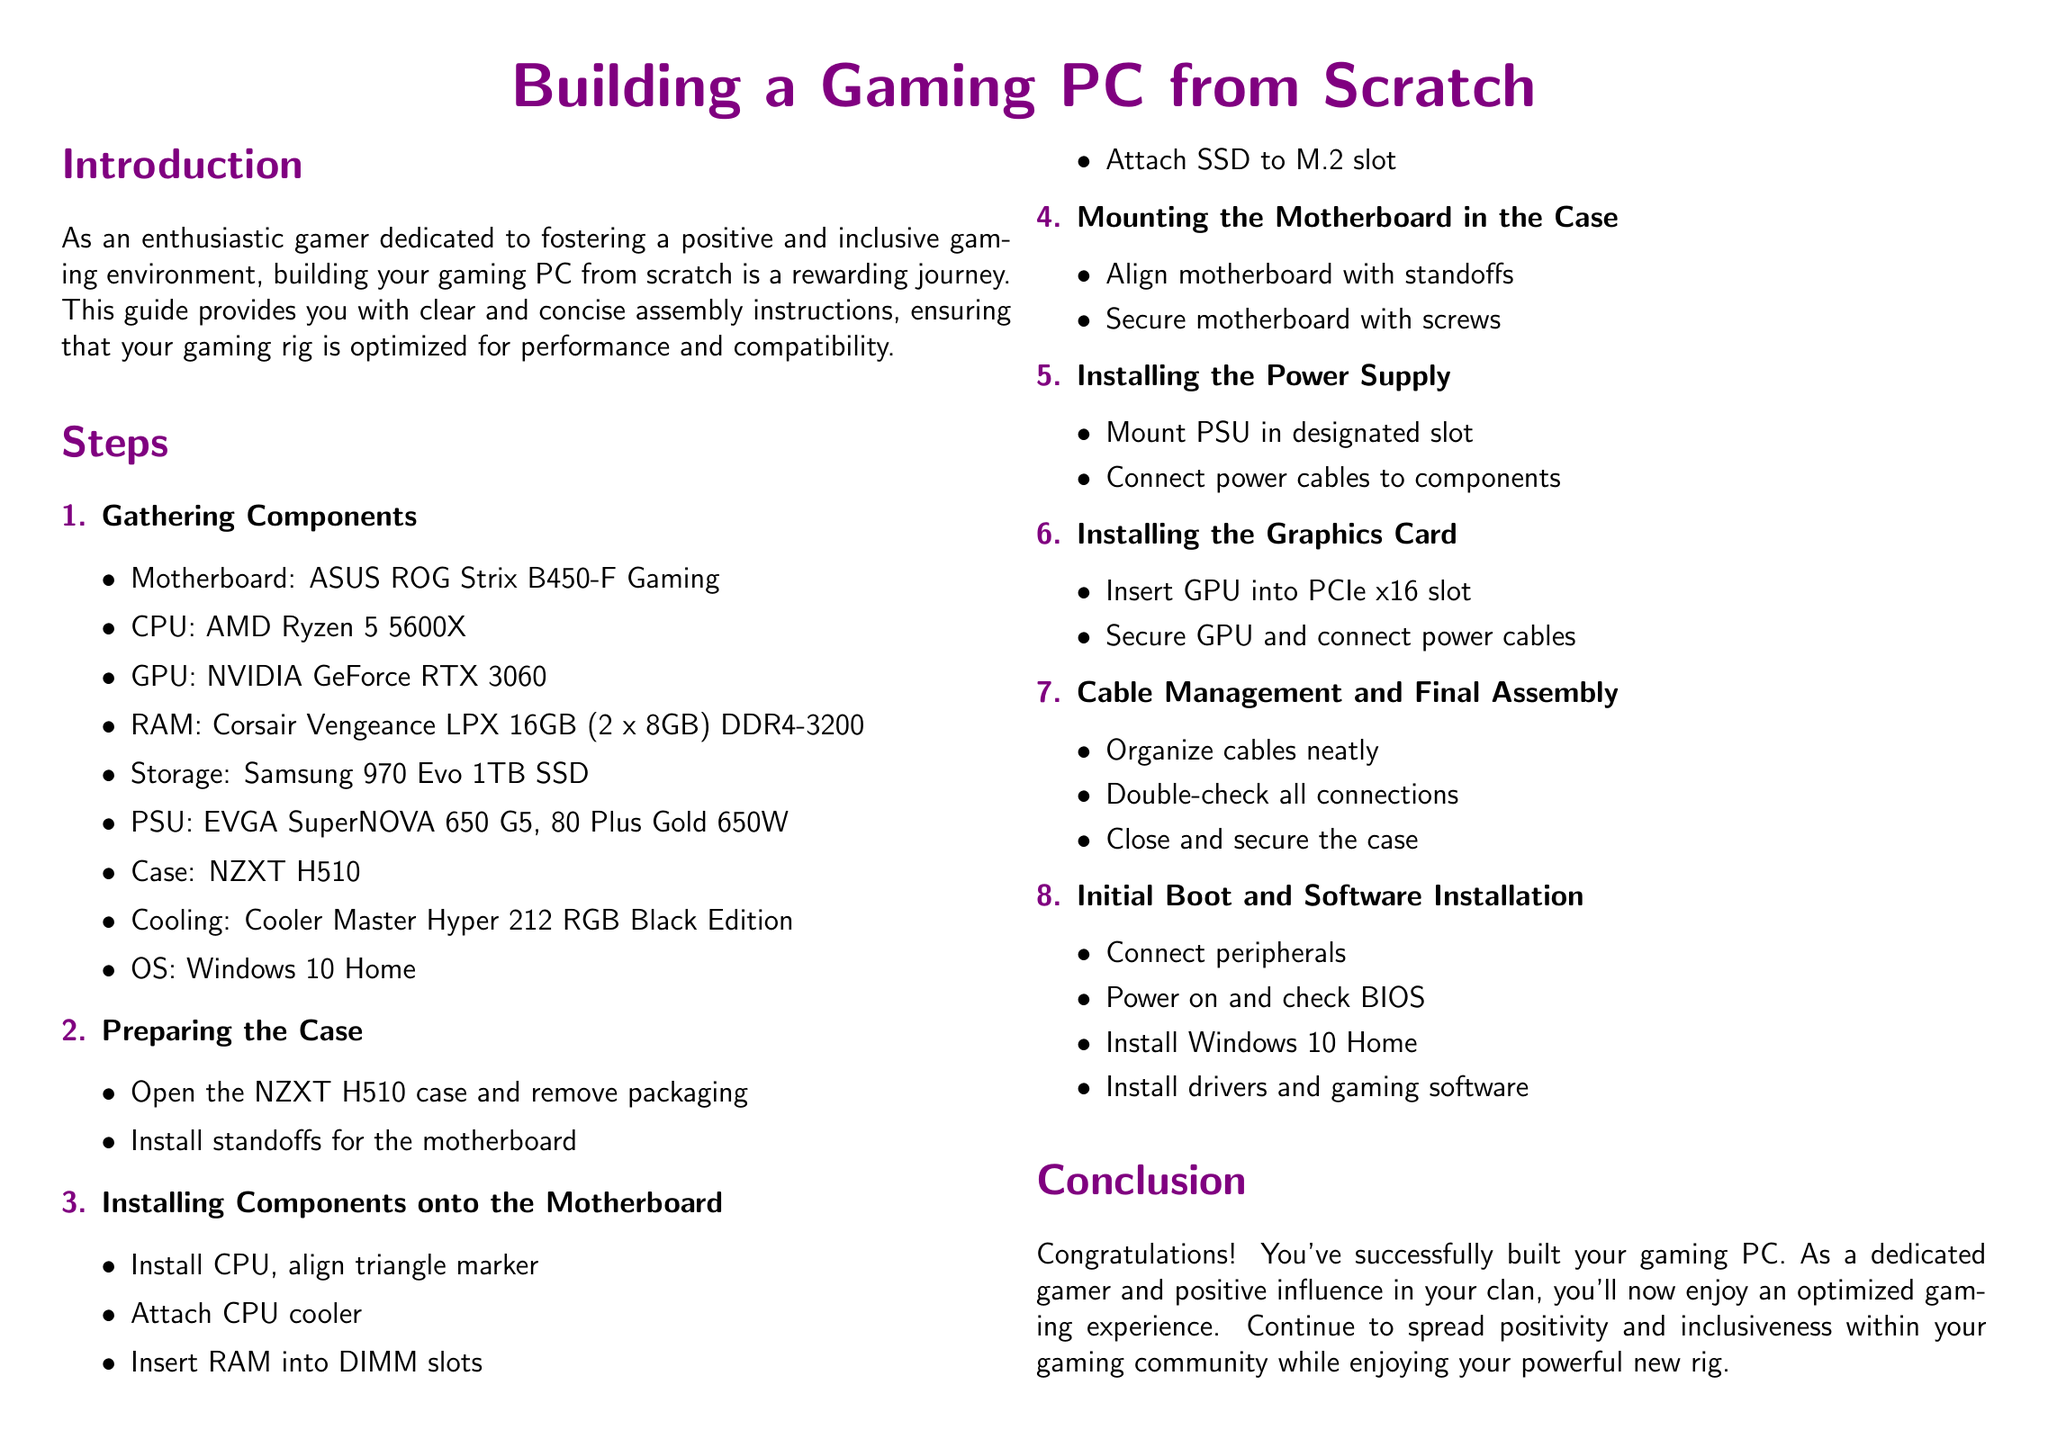What is the model of the motherboard? The motherboard specified in the document is the ASUS ROG Strix B450-F Gaming.
Answer: ASUS ROG Strix B450-F Gaming How many RAM sticks are used in the build? The document mentions two sticks of 8GB RAM, totaling 16GB.
Answer: 2 What is the total power supply wattage? The specified power supply in the document is 650W.
Answer: 650W Which CPU is used in the gaming PC? The CPU listed in the assembly instructions is the AMD Ryzen 5 5600X.
Answer: AMD Ryzen 5 5600X What is the storage type mentioned in the document? The storage device specified is a Samsung SSD, model 970 Evo.
Answer: SSD What step involves organizing cables? Cable management and final assembly is the step where cables are organized.
Answer: Cable management and final assembly What should you check after powering on the PC? You should check the BIOS after powering on the gaming PC.
Answer: BIOS Which operating system is installed? The operating system mentioned in the document is Windows 10 Home.
Answer: Windows 10 Home What is one tip given for component compatibility? One tip is to ensure component compatibility before purchase.
Answer: Ensure component compatibility before purchase 